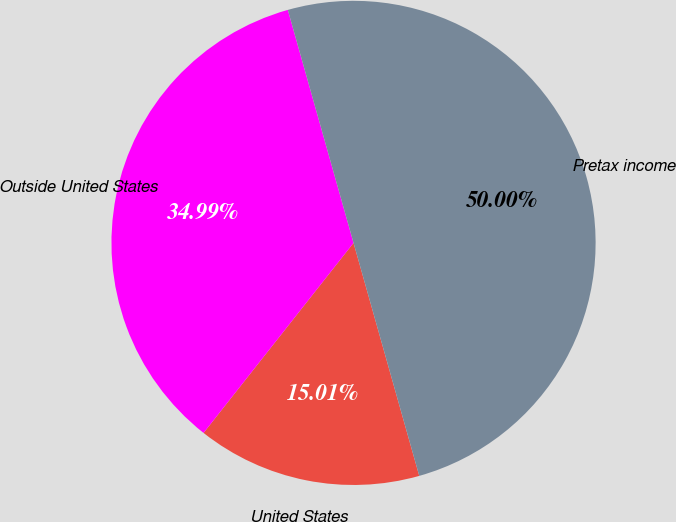<chart> <loc_0><loc_0><loc_500><loc_500><pie_chart><fcel>United States<fcel>Outside United States<fcel>Pretax income<nl><fcel>15.01%<fcel>34.99%<fcel>50.0%<nl></chart> 